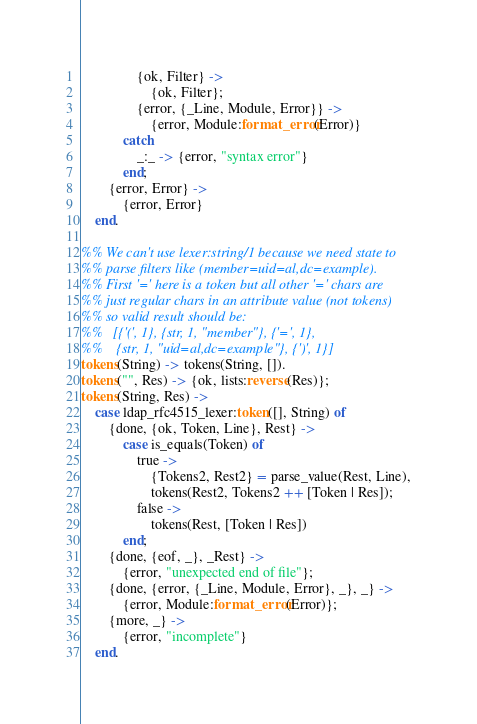Convert code to text. <code><loc_0><loc_0><loc_500><loc_500><_Erlang_>                {ok, Filter} ->
                    {ok, Filter};
                {error, {_Line, Module, Error}} ->
                    {error, Module:format_error(Error)}
            catch
                _:_ -> {error, "syntax error"}
            end;
        {error, Error} ->
            {error, Error}
    end.

%% We can't use lexer:string/1 because we need state to
%% parse filters like (member=uid=al,dc=example).
%% First '=' here is a token but all other '=' chars are
%% just regular chars in an attribute value (not tokens)
%% so valid result should be:
%%   [{'(', 1}, {str, 1, "member"}, {'=', 1},
%%    {str, 1, "uid=al,dc=example"}, {')', 1}]
tokens(String) -> tokens(String, []).
tokens("", Res) -> {ok, lists:reverse(Res)};
tokens(String, Res) ->
    case ldap_rfc4515_lexer:token([], String) of
        {done, {ok, Token, Line}, Rest} ->
            case is_equals(Token) of
                true ->
                    {Tokens2, Rest2} = parse_value(Rest, Line),
                    tokens(Rest2, Tokens2 ++ [Token | Res]);
                false ->
                    tokens(Rest, [Token | Res])
            end;
        {done, {eof, _}, _Rest} ->
            {error, "unexpected end of file"};
        {done, {error, {_Line, Module, Error}, _}, _} ->
            {error, Module:format_error(Error)};
        {more, _} ->
            {error, "incomplete"}
    end.
</code> 